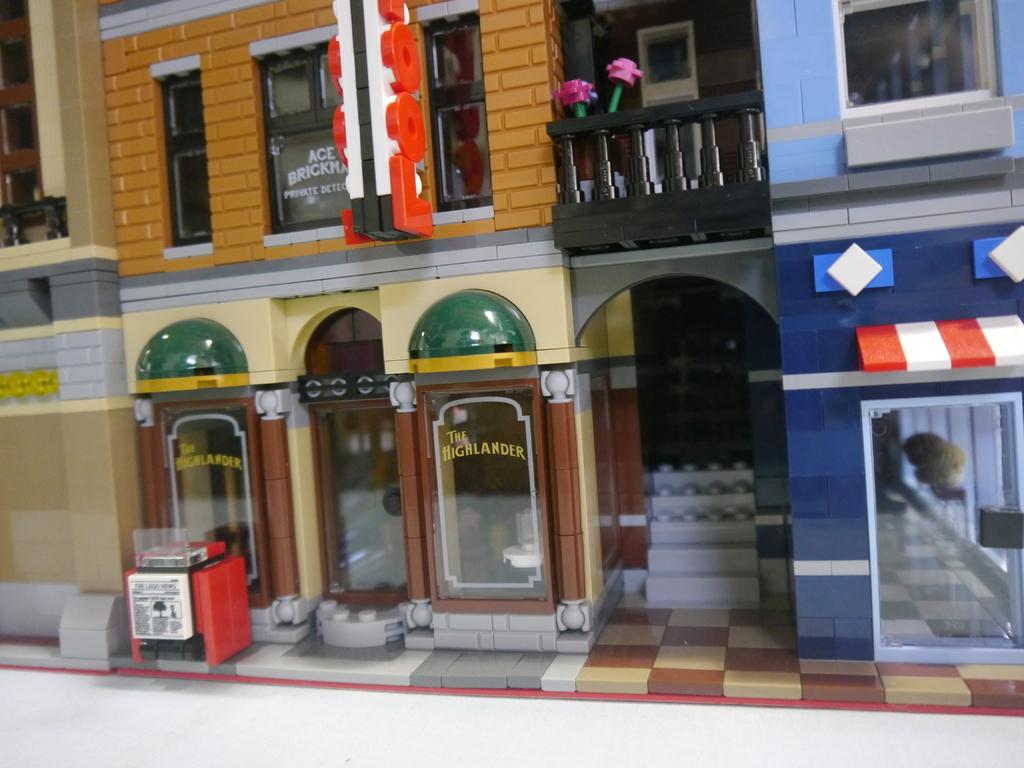<image>
Render a clear and concise summary of the photo. Store front with yellow wording that says The Highlander. 